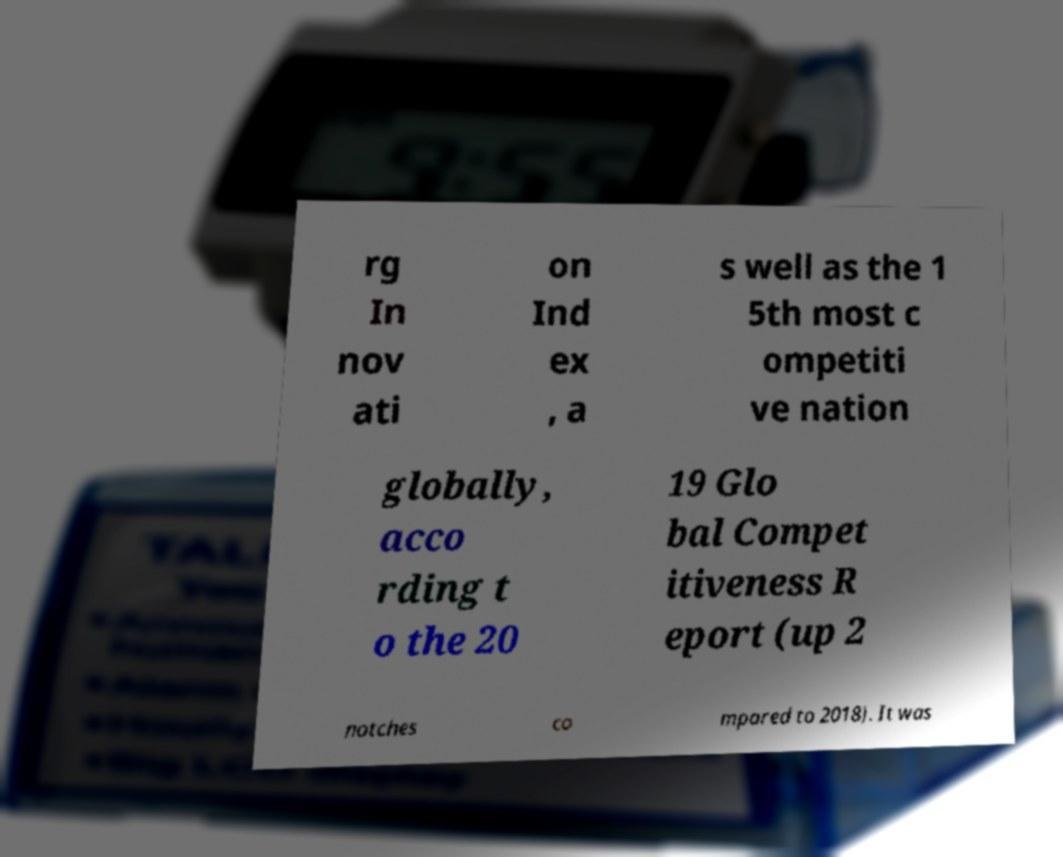Please read and relay the text visible in this image. What does it say? rg In nov ati on Ind ex , a s well as the 1 5th most c ompetiti ve nation globally, acco rding t o the 20 19 Glo bal Compet itiveness R eport (up 2 notches co mpared to 2018). It was 